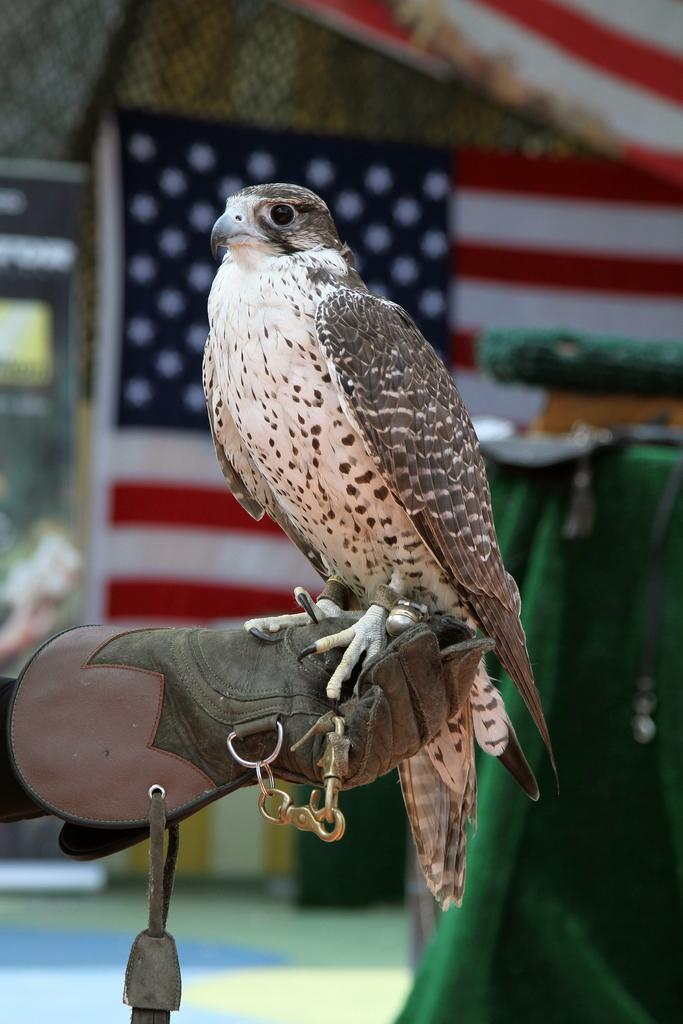What type of bird is in the picture? There is a white and brown color eagle in the picture. What is the eagle doing in the picture? The eagle is sitting on a person's hand. What is the person wearing on their hand? The person is wearing a glove. What can be seen in the background of the picture? There is an American flag in the background of the picture. How is the background of the picture depicted? The background is blurred. What news is the eagle delivering in the image? There is no news or delivery mentioned or depicted in the image. The image only shows an eagle sitting on a person's hand, with a blurred background featuring an American flag. 